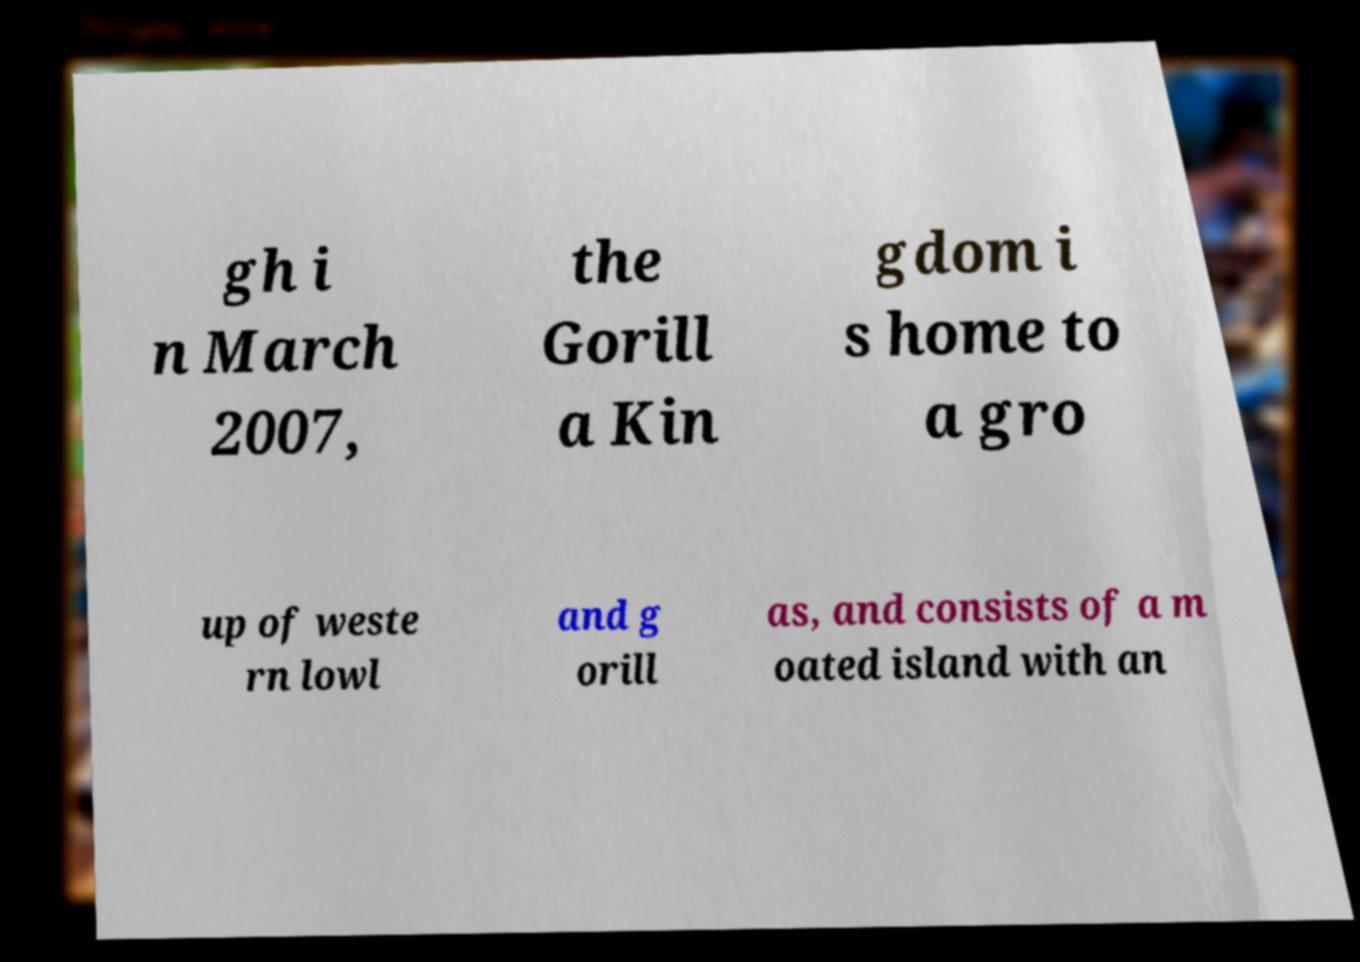Can you read and provide the text displayed in the image?This photo seems to have some interesting text. Can you extract and type it out for me? gh i n March 2007, the Gorill a Kin gdom i s home to a gro up of weste rn lowl and g orill as, and consists of a m oated island with an 